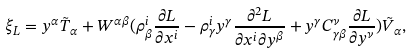Convert formula to latex. <formula><loc_0><loc_0><loc_500><loc_500>\xi _ { L } = y ^ { \alpha } \tilde { T } _ { \alpha } + W ^ { \alpha \beta } ( \rho ^ { i } _ { \beta } \frac { \partial L } { \partial x ^ { i } } - \rho _ { \gamma } ^ { i } y ^ { \gamma } \frac { \partial ^ { 2 } L } { \partial x ^ { i } \partial y ^ { \beta } } + y ^ { \gamma } C _ { \gamma \beta } ^ { \nu } \frac { \partial L } { \partial y ^ { \nu } } ) \tilde { V } _ { \alpha } ,</formula> 